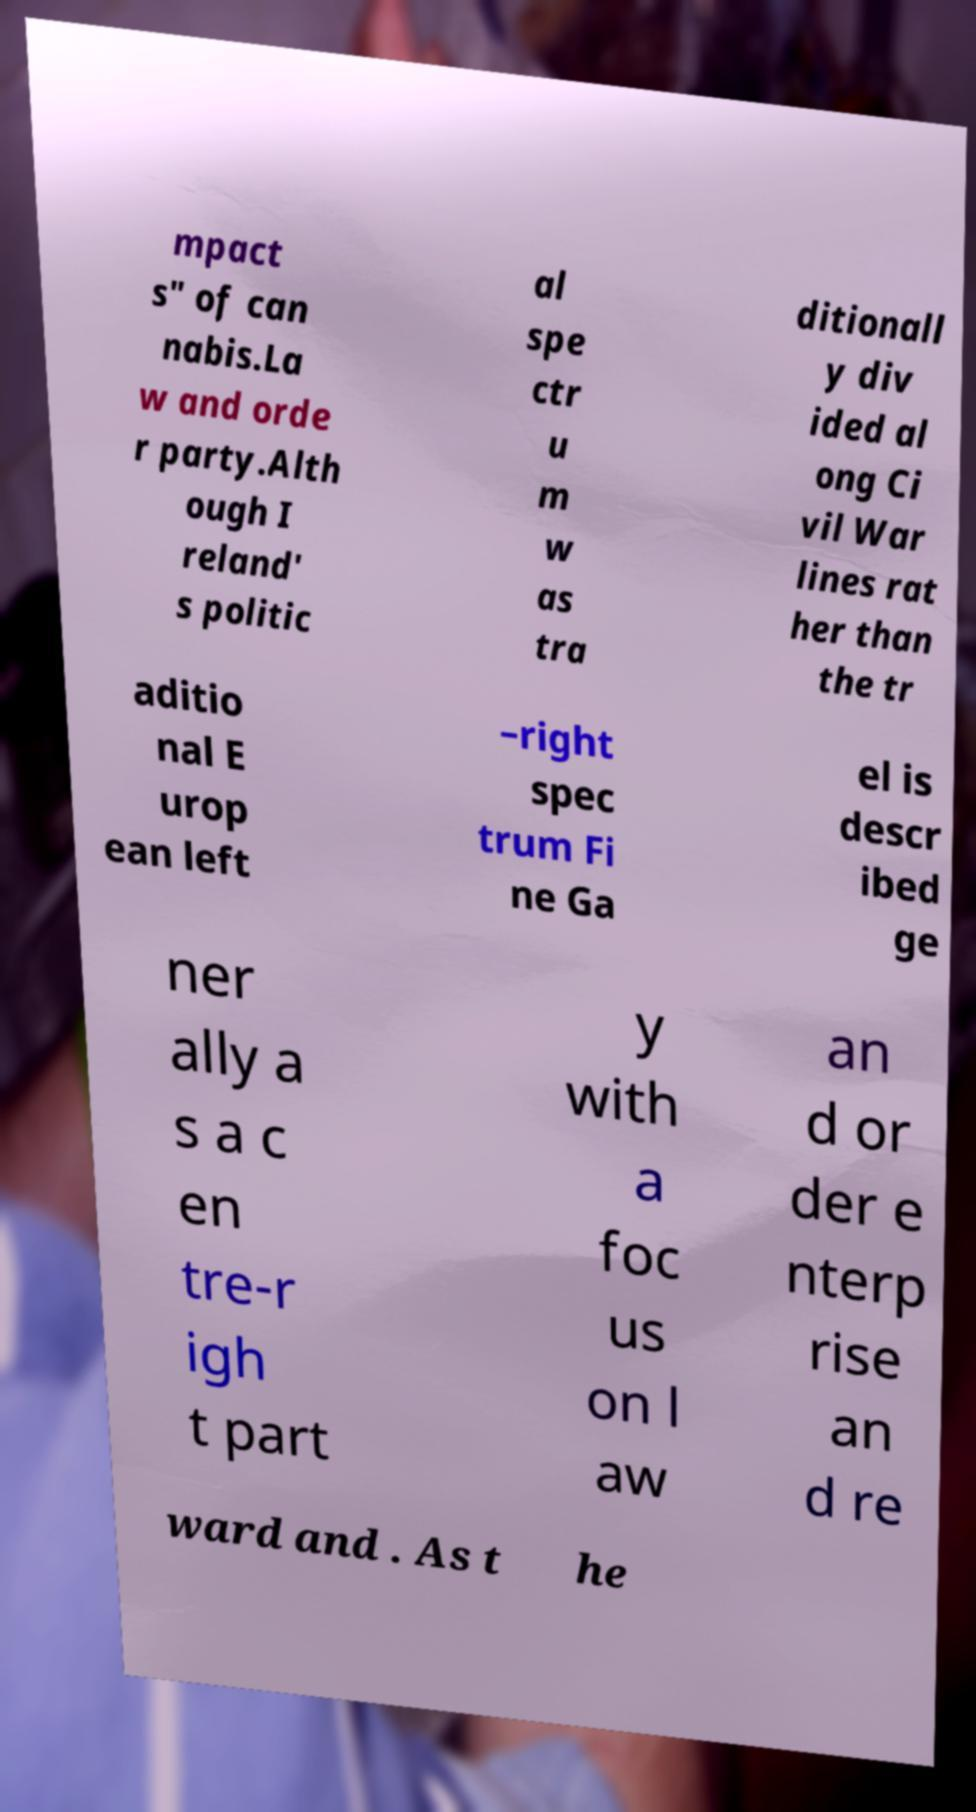There's text embedded in this image that I need extracted. Can you transcribe it verbatim? mpact s" of can nabis.La w and orde r party.Alth ough I reland' s politic al spe ctr u m w as tra ditionall y div ided al ong Ci vil War lines rat her than the tr aditio nal E urop ean left –right spec trum Fi ne Ga el is descr ibed ge ner ally a s a c en tre-r igh t part y with a foc us on l aw an d or der e nterp rise an d re ward and . As t he 